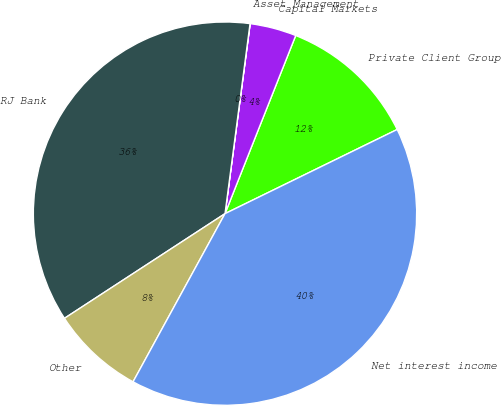Convert chart to OTSL. <chart><loc_0><loc_0><loc_500><loc_500><pie_chart><fcel>Private Client Group<fcel>Capital Markets<fcel>Asset Management<fcel>RJ Bank<fcel>Other<fcel>Net interest income<nl><fcel>11.75%<fcel>3.92%<fcel>0.01%<fcel>36.28%<fcel>7.84%<fcel>40.2%<nl></chart> 